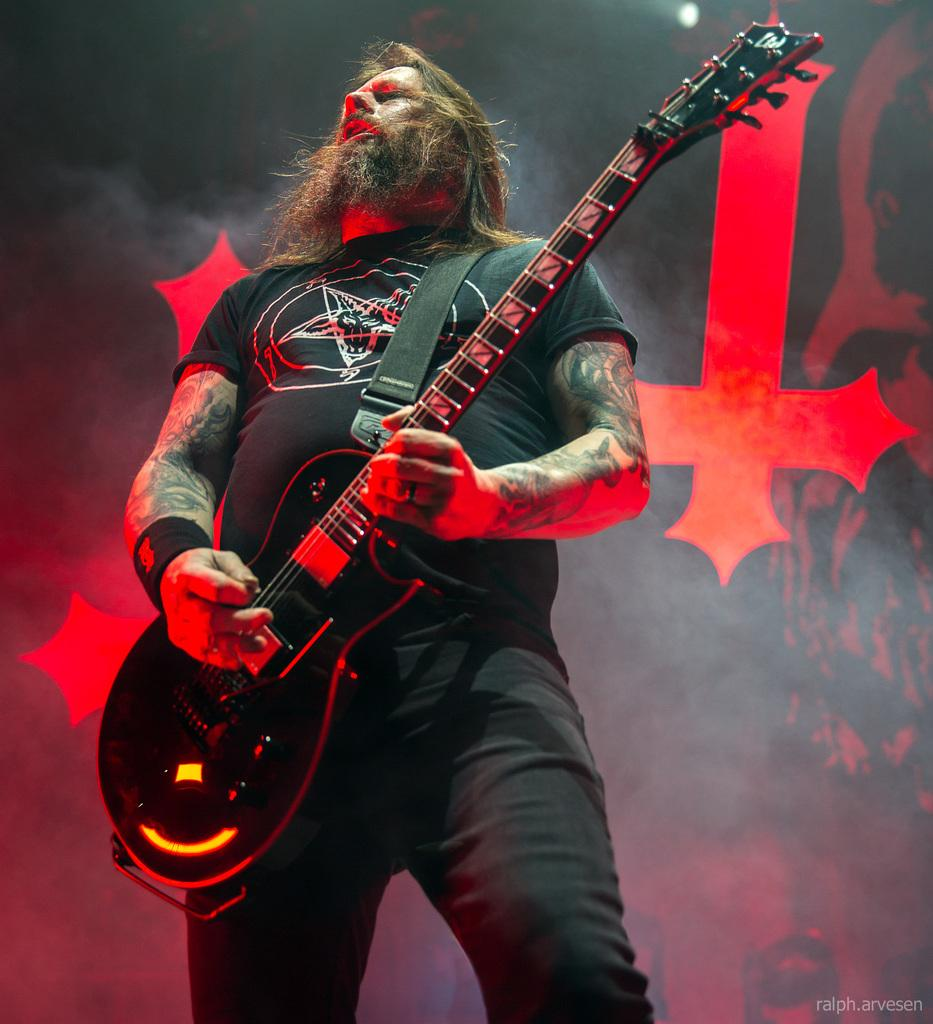What is the main subject of the image? There is a person in the image. What is the person doing in the image? The person is standing in the image. What object is the person holding in the image? The person is holding a guitar in his hands. What type of smile can be seen on the moon in the image? There is no moon present in the image. 